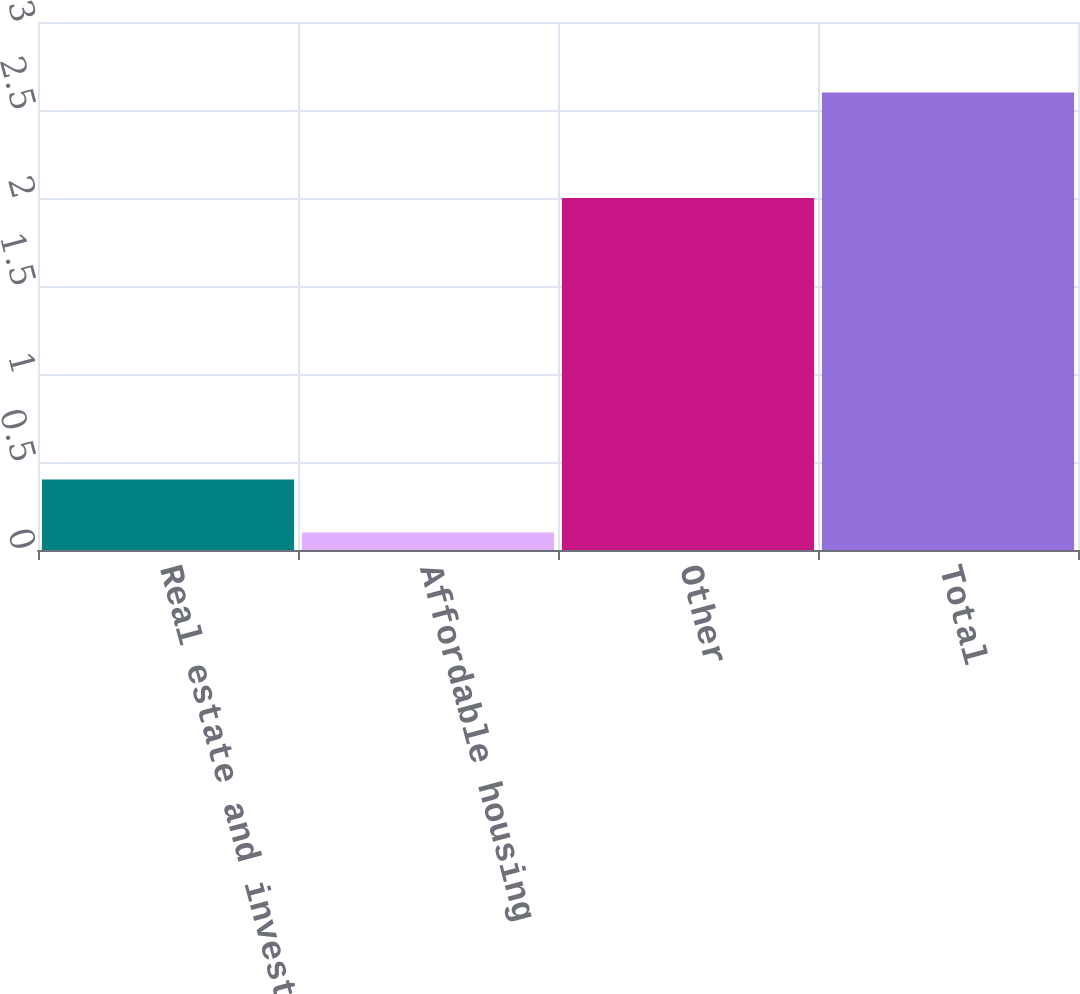<chart> <loc_0><loc_0><loc_500><loc_500><bar_chart><fcel>Real estate and investment<fcel>Affordable housing<fcel>Other<fcel>Total<nl><fcel>0.4<fcel>0.1<fcel>2<fcel>2.6<nl></chart> 